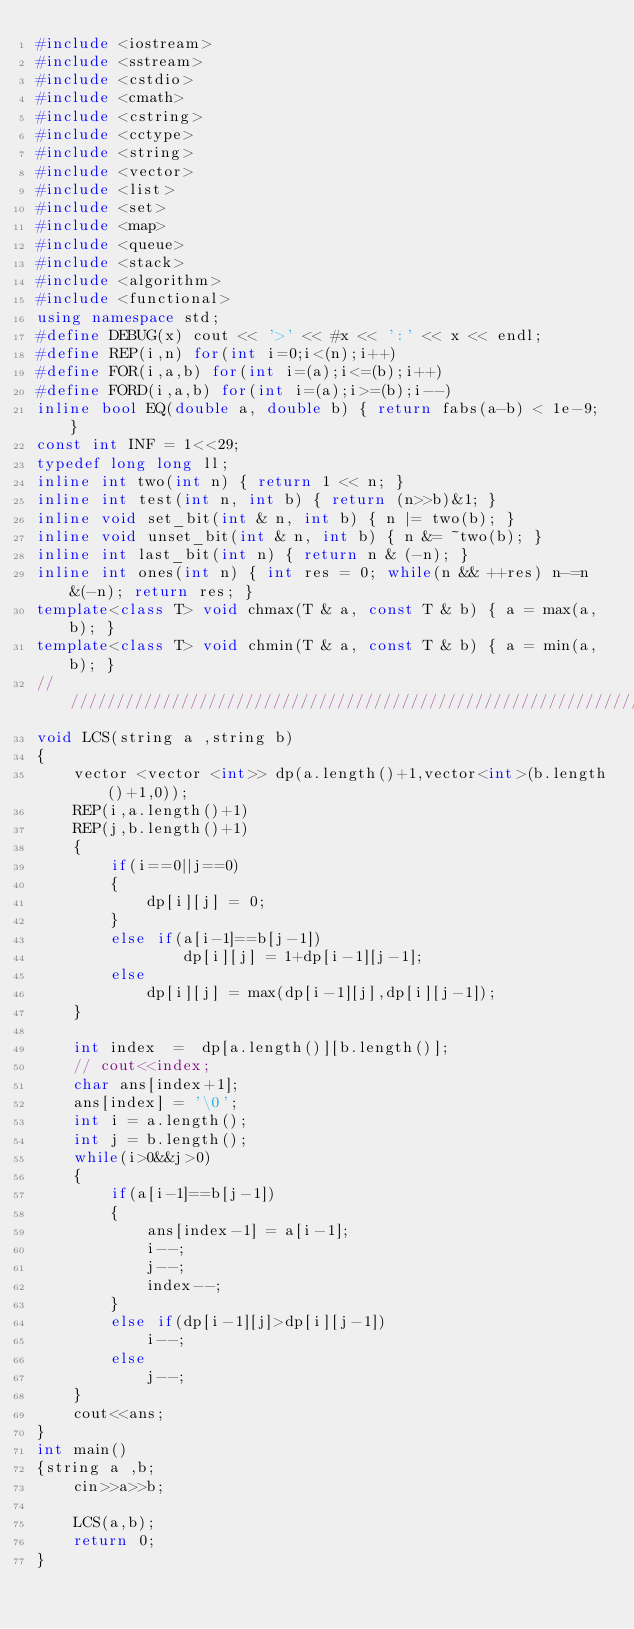<code> <loc_0><loc_0><loc_500><loc_500><_C++_>#include <iostream>
#include <sstream>
#include <cstdio>
#include <cmath>
#include <cstring>
#include <cctype>
#include <string>
#include <vector>
#include <list>
#include <set>
#include <map>
#include <queue>
#include <stack>
#include <algorithm>
#include <functional>
using namespace std; 
#define DEBUG(x) cout << '>' << #x << ':' << x << endl;
#define REP(i,n) for(int i=0;i<(n);i++)
#define FOR(i,a,b) for(int i=(a);i<=(b);i++)
#define FORD(i,a,b) for(int i=(a);i>=(b);i--)
inline bool EQ(double a, double b) { return fabs(a-b) < 1e-9; }
const int INF = 1<<29;
typedef long long ll;
inline int two(int n) { return 1 << n; }
inline int test(int n, int b) { return (n>>b)&1; }
inline void set_bit(int & n, int b) { n |= two(b); }
inline void unset_bit(int & n, int b) { n &= ~two(b); }
inline int last_bit(int n) { return n & (-n); }
inline int ones(int n) { int res = 0; while(n && ++res) n-=n&(-n); return res; }
template<class T> void chmax(T & a, const T & b) { a = max(a, b); }
template<class T> void chmin(T & a, const T & b) { a = min(a, b); }
/////////////////////////////////////////////////////////////////////
void LCS(string a ,string b)
{
	vector <vector <int>> dp(a.length()+1,vector<int>(b.length()+1,0));
	REP(i,a.length()+1)
	REP(j,b.length()+1)
	{
		if(i==0||j==0)
		{
			dp[i][j] = 0;
		}
		else if(a[i-1]==b[j-1])
				dp[i][j] = 1+dp[i-1][j-1];
		else 
			dp[i][j] = max(dp[i-1][j],dp[i][j-1]);
	}

	int index  =  dp[a.length()][b.length()];
	// cout<<index;
	char ans[index+1];
	ans[index] = '\0';
	int i = a.length();
	int j = b.length();
	while(i>0&&j>0)
	{
		if(a[i-1]==b[j-1])
		{
			ans[index-1] = a[i-1];
			i--;
			j--;
			index--;
		}
		else if(dp[i-1][j]>dp[i][j-1])
			i--;
		else
			j--;
	}
	cout<<ans;
}
int main()
{string a ,b;
	cin>>a>>b;

    LCS(a,b);
    return 0;
}</code> 